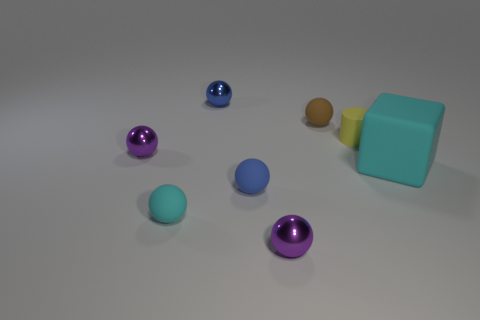Is there any other thing that is the same size as the cyan rubber cube?
Provide a short and direct response. No. What is the yellow object made of?
Offer a very short reply. Rubber. Is there anything else that has the same color as the big object?
Provide a short and direct response. Yes. Do the big cyan thing and the brown thing have the same material?
Provide a short and direct response. Yes. How many tiny purple things are in front of the tiny blue thing that is in front of the tiny rubber thing behind the small yellow matte cylinder?
Your response must be concise. 1. What number of blue things are there?
Offer a terse response. 2. Is the number of cylinders to the left of the tiny cyan matte object less than the number of tiny purple metallic objects behind the yellow rubber object?
Your answer should be very brief. No. Are there fewer balls that are right of the big matte block than small yellow cylinders?
Your response must be concise. Yes. What is the ball right of the purple thing that is in front of the tiny purple ball to the left of the tiny blue rubber thing made of?
Keep it short and to the point. Rubber. What number of things are either tiny blue spheres that are to the left of the brown rubber object or tiny objects that are behind the yellow object?
Your answer should be very brief. 3. 